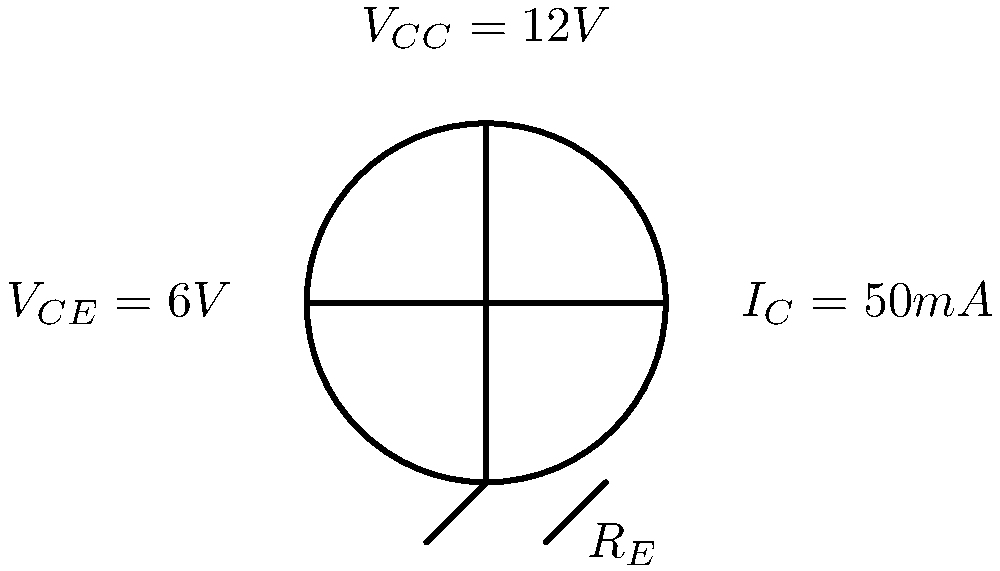Hey mate, I noticed you've got a fancy transistor circuit on your workbench. Mind if I ask you a quick question about it? If the collector current ($I_C$) is 50mA and the collector-emitter voltage ($V_{CE}$) is 6V, what's the power dissipation in the transistor? Certainly! Let's work through this step-by-step:

1) The power dissipation in a transistor is primarily due to the collector-emitter current and voltage. We can calculate it using the formula:

   $P = V_{CE} \times I_C$

2) We're given:
   $V_{CE} = 6V$
   $I_C = 50mA = 0.05A$

3) Let's substitute these values into our formula:

   $P = 6V \times 0.05A$

4) Now, let's calculate:

   $P = 0.3W$ or $300mW$

So, the power dissipation in the transistor is 0.3 watts or 300 milliwatts.
Answer: $0.3W$ or $300mW$ 